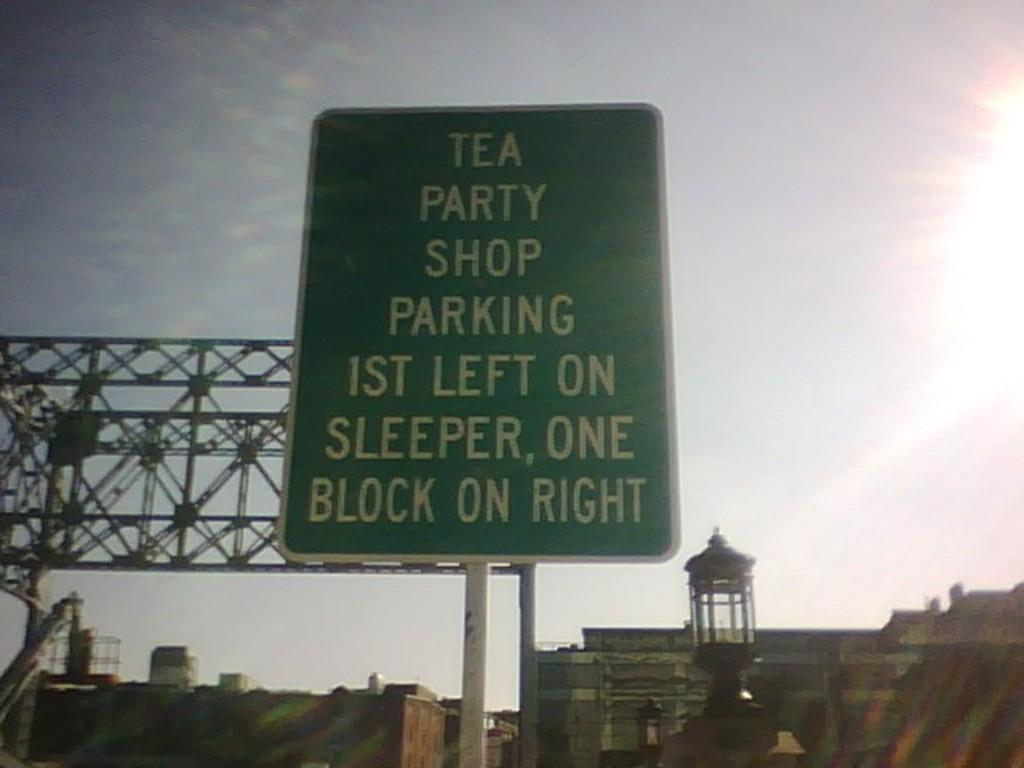<image>
Give a short and clear explanation of the subsequent image. A sign which indicates directions for the parking area for a the Tea Party Shop. 